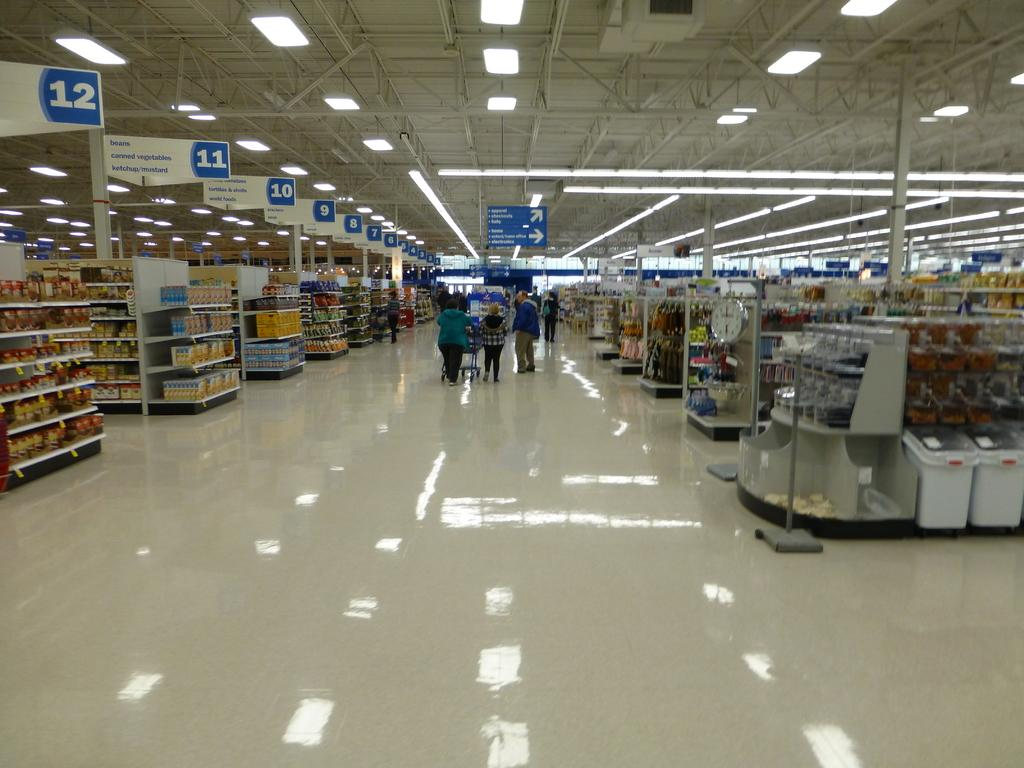<image>
Summarize the visual content of the image. A family is pushing a cart passed aisle 10 in a large shopping center. 